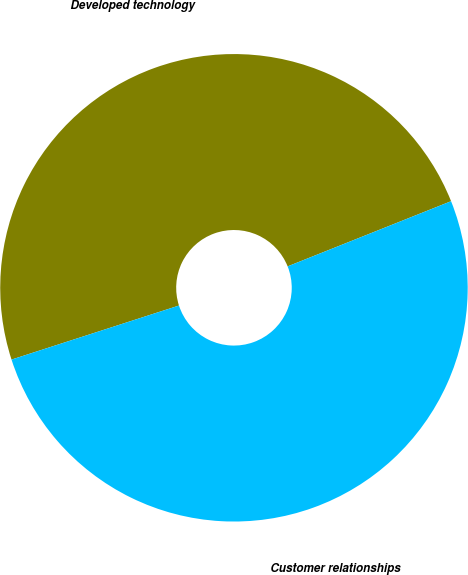<chart> <loc_0><loc_0><loc_500><loc_500><pie_chart><fcel>Developed technology<fcel>Customer relationships<nl><fcel>48.93%<fcel>51.07%<nl></chart> 